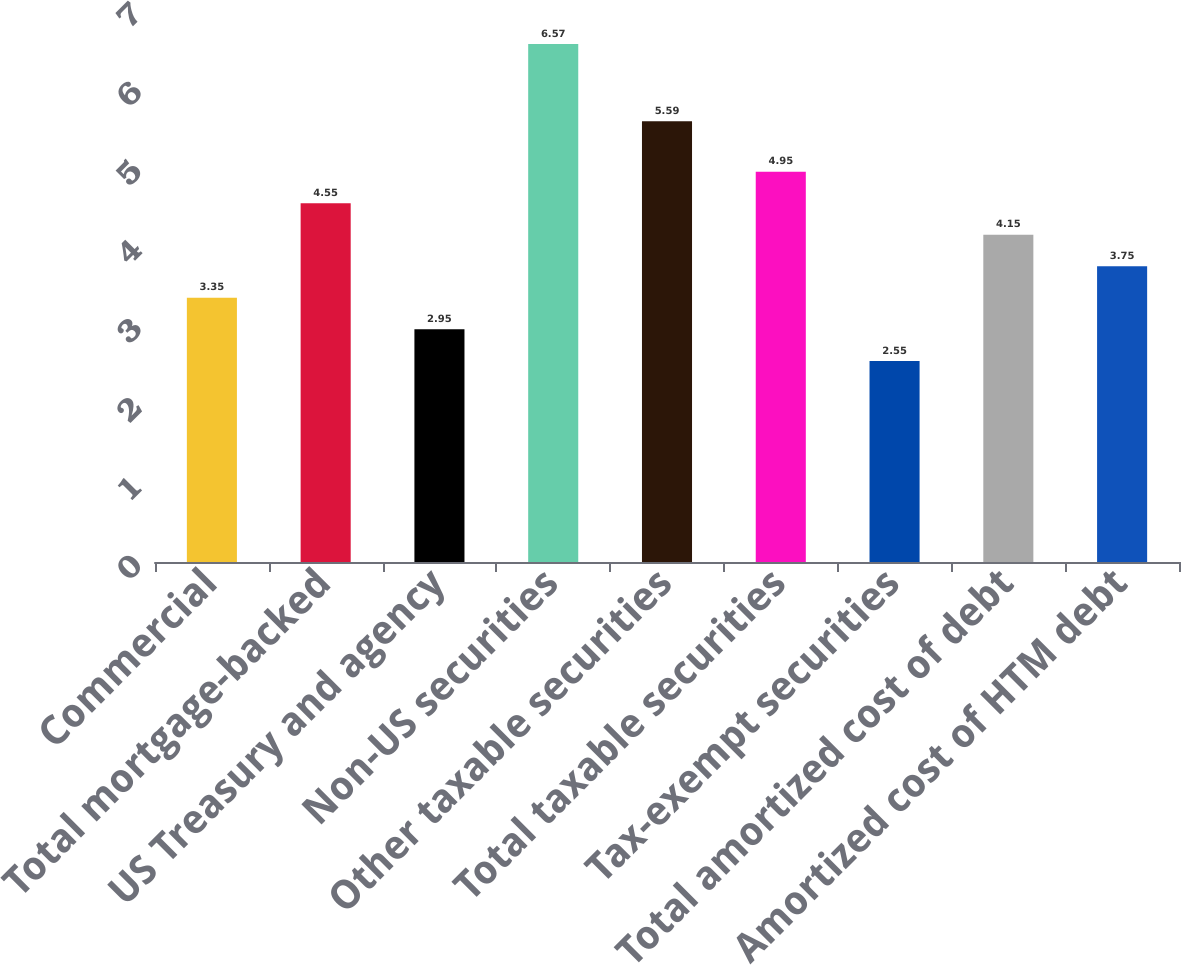Convert chart. <chart><loc_0><loc_0><loc_500><loc_500><bar_chart><fcel>Commercial<fcel>Total mortgage-backed<fcel>US Treasury and agency<fcel>Non-US securities<fcel>Other taxable securities<fcel>Total taxable securities<fcel>Tax-exempt securities<fcel>Total amortized cost of debt<fcel>Amortized cost of HTM debt<nl><fcel>3.35<fcel>4.55<fcel>2.95<fcel>6.57<fcel>5.59<fcel>4.95<fcel>2.55<fcel>4.15<fcel>3.75<nl></chart> 